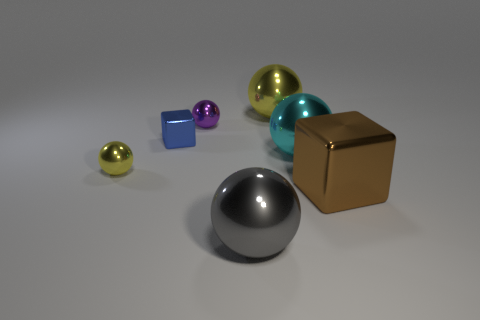Subtract all small purple metallic balls. How many balls are left? 4 Subtract all brown blocks. How many blocks are left? 1 Add 1 large gray matte cylinders. How many objects exist? 8 Subtract all cubes. How many objects are left? 5 Subtract 1 spheres. How many spheres are left? 4 Subtract all small matte things. Subtract all cyan metallic objects. How many objects are left? 6 Add 7 tiny things. How many tiny things are left? 10 Add 1 tiny objects. How many tiny objects exist? 4 Subtract 0 yellow cubes. How many objects are left? 7 Subtract all blue spheres. Subtract all green blocks. How many spheres are left? 5 